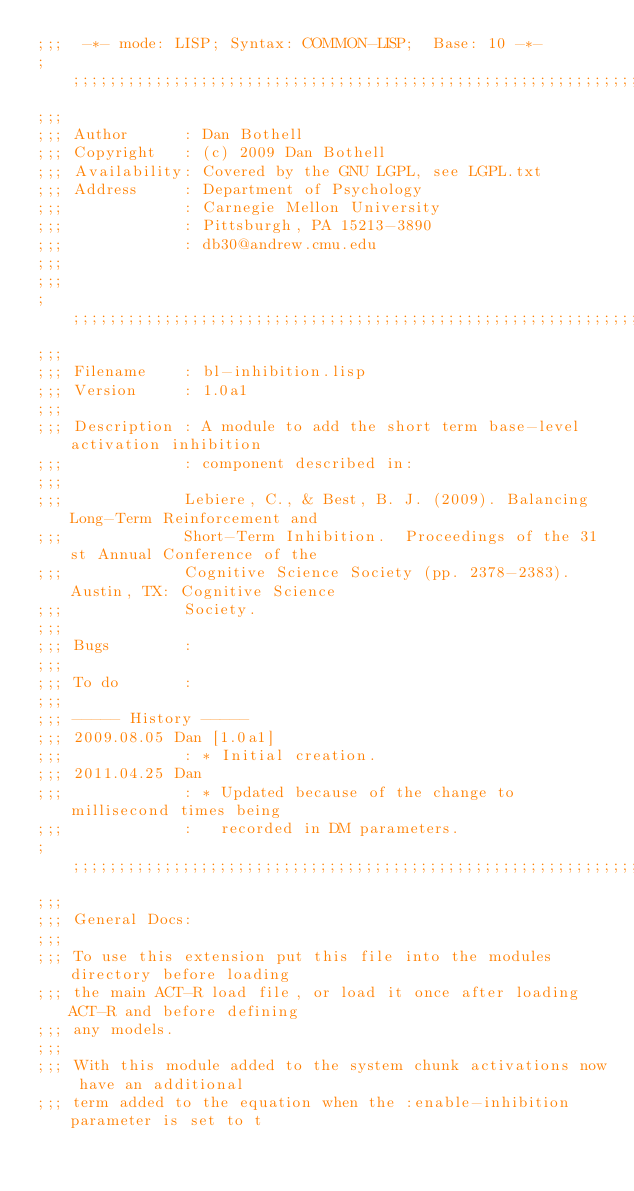<code> <loc_0><loc_0><loc_500><loc_500><_Lisp_>;;;  -*- mode: LISP; Syntax: COMMON-LISP;  Base: 10 -*-
;;;;;;;;;;;;;;;;;;;;;;;;;;;;;;;;;;;;;;;;;;;;;;;;;;;;;;;;;;;;;;;;;;;;;;;;;;;;;;;;
;;; 
;;; Author      : Dan Bothell
;;; Copyright   : (c) 2009 Dan Bothell
;;; Availability: Covered by the GNU LGPL, see LGPL.txt
;;; Address     : Department of Psychology 
;;;             : Carnegie Mellon University
;;;             : Pittsburgh, PA 15213-3890
;;;             : db30@andrew.cmu.edu
;;; 
;;; 
;;;;;;;;;;;;;;;;;;;;;;;;;;;;;;;;;;;;;;;;;;;;;;;;;;;;;;;;;;;;;;;;;;;;;;;;;;;;;;;;
;;; 
;;; Filename    : bl-inhibition.lisp
;;; Version     : 1.0a1
;;; 
;;; Description : A module to add the short term base-level activation inhibition 
;;;             : component described in:
;;;
;;;             Lebiere, C., & Best, B. J. (2009). Balancing Long-Term Reinforcement and
;;;             Short-Term Inhibition.  Proceedings of the 31st Annual Conference of the
;;;             Cognitive Science Society (pp. 2378-2383).  Austin, TX: Cognitive Science
;;;             Society.
;;;
;;; Bugs        : 
;;;
;;; To do       : 
;;; 
;;; ----- History -----
;;; 2009.08.05 Dan [1.0a1]
;;;             : * Initial creation.
;;; 2011.04.25 Dan
;;;             : * Updated because of the change to millisecond times being
;;;             :   recorded in DM parameters.
;;;;;;;;;;;;;;;;;;;;;;;;;;;;;;;;;;;;;;;;;;;;;;;;;;;;;;;;;;;;;;;;;;;;;;;;;;;;;;;;
;;;
;;; General Docs:
;;; 
;;; To use this extension put this file into the modules directory before loading
;;; the main ACT-R load file, or load it once after loading ACT-R and before defining
;;; any models.
;;;
;;; With this module added to the system chunk activations now have an additional
;;; term added to the equation when the :enable-inhibition parameter is set to t</code> 